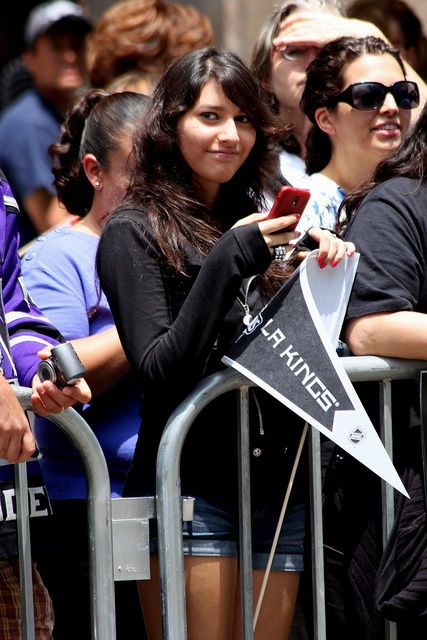Describe the objects in this image and their specific colors. I can see people in black, maroon, gray, and brown tones, people in black, lavender, lightblue, and brown tones, people in black, brown, white, and maroon tones, people in black and gray tones, and people in black, maroon, and gray tones in this image. 